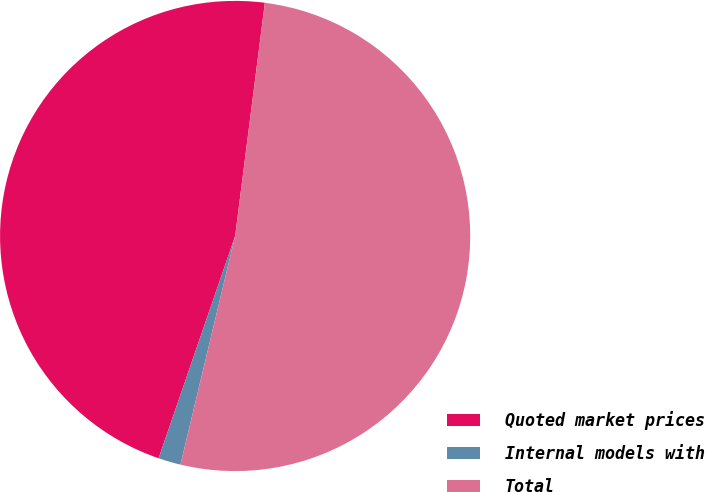Convert chart to OTSL. <chart><loc_0><loc_0><loc_500><loc_500><pie_chart><fcel>Quoted market prices<fcel>Internal models with<fcel>Total<nl><fcel>46.74%<fcel>1.54%<fcel>51.72%<nl></chart> 